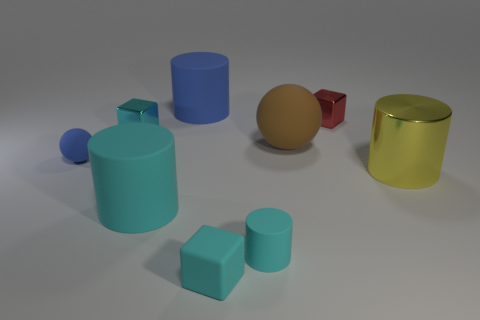Add 1 balls. How many objects exist? 10 Subtract all gray cylinders. Subtract all brown balls. How many cylinders are left? 4 Subtract all blocks. How many objects are left? 6 Add 3 gray matte cylinders. How many gray matte cylinders exist? 3 Subtract 0 purple cylinders. How many objects are left? 9 Subtract all small balls. Subtract all shiny blocks. How many objects are left? 6 Add 5 big blue things. How many big blue things are left? 6 